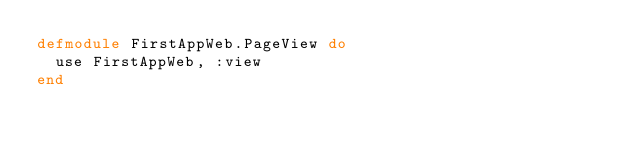Convert code to text. <code><loc_0><loc_0><loc_500><loc_500><_Elixir_>defmodule FirstAppWeb.PageView do
  use FirstAppWeb, :view
end
</code> 